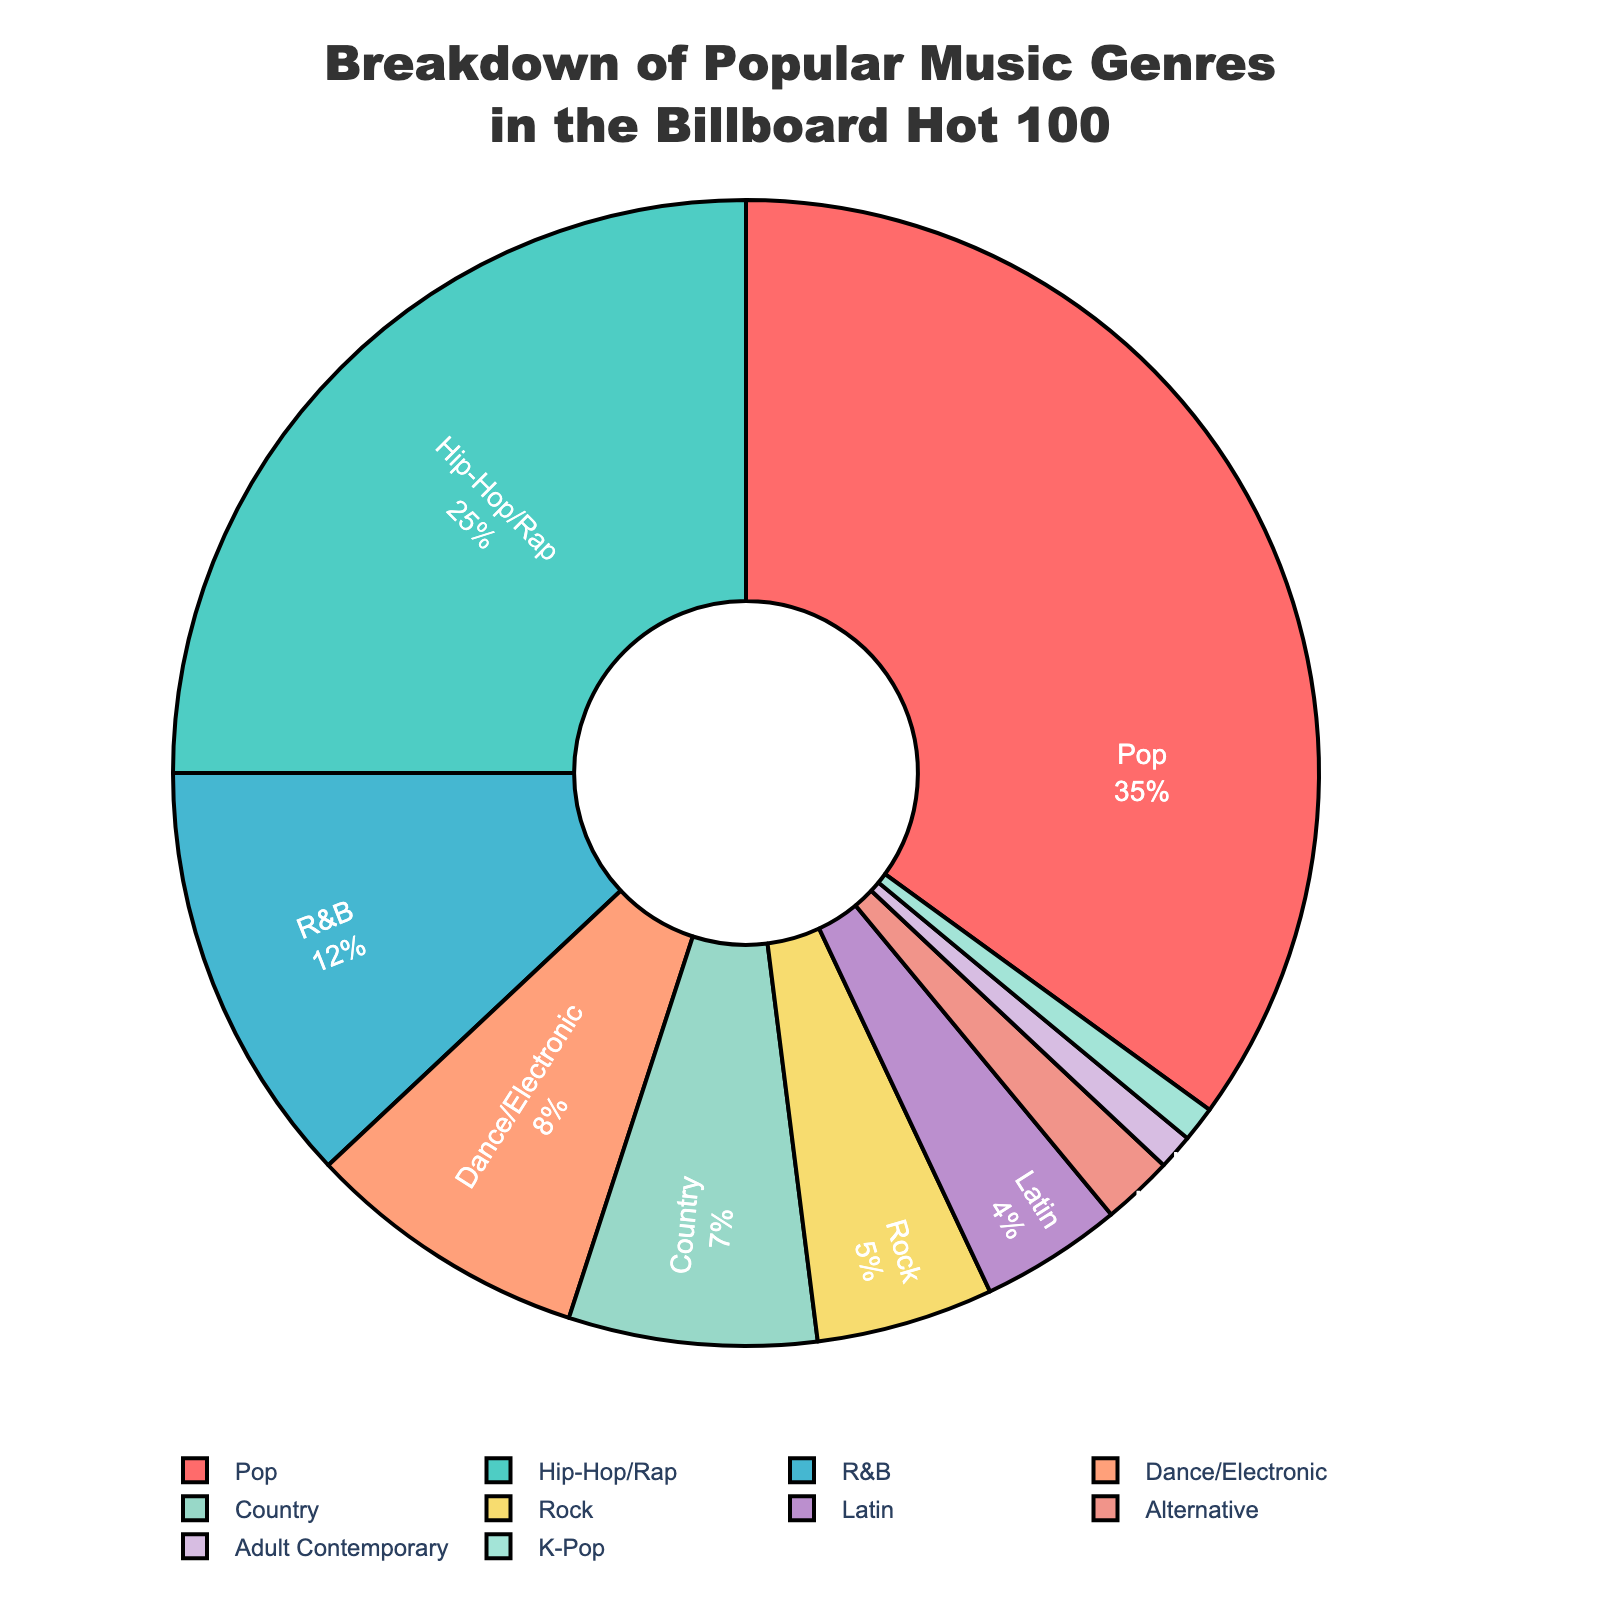What's the most popular music genre in the Billboard Hot 100? The pie chart shows the percentage breakdown of popular music genres, and the genre with the largest percentage is Pop at 35%.
Answer: Pop What's the combined percentage of Hip-Hop/Rap, R&B, and Dance/Electronic genres? To find the combined percentage, add the percentages of Hip-Hop/Rap (25%), R&B (12%), and Dance/Electronic (8%): 25 + 12 + 8 = 45.
Answer: 45 How much more popular is Pop compared to Country in this chart? The percentage for Pop is 35% and for Country is 7%. To find the difference, subtract the percentage of Country from Pop: 35 - 7 = 28.
Answer: 28 Which genre accounts for the smallest percentage of the Billboard Hot 100? The pie chart shows that both Adult Contemporary and K-Pop have the smallest percentages, each at 1%.
Answer: Adult Contemporary and K-Pop If Adult Contemporary and K-Pop were combined into one category, what would be their total percentage? Both Adult Contemporary and K-Pop individually account for 1%, so combined they would account for: 1 + 1 = 2.
Answer: 2 Is the percentage of Pop music more than double that of Hip-Hop/Rap? The percentage of Pop music is 35%, and that of Hip-Hop/Rap is 25%. Double of Hip-Hop/Rap would be 25 × 2 = 50. Since 35% is less than 50%, Pop is not more than double.
Answer: No Which genre has a higher percentage, Rock or Latin? The pie chart shows that Rock accounts for 5% while Latin accounts for 4%. Therefore, Rock has a higher percentage.
Answer: Rock What's the total percentage of genres accounting for less than 10% each? To find the total, add the percentages of R&B (12%), Dance/Electronic (8%), Country (7%), Rock (5%), Latin (4%), Alternative (2%), Adult Contemporary (1%), and K-Pop (1%): 12 + 8 + 7 + 5 + 4 + 2 + 1 + 1 = 40.
Answer: 40 How much more popular is Hip-Hop/Rap compared to Dance/Electronic? The percentage for Hip-Hop/Rap is 25% and for Dance/Electronic is 8%. To find the difference, subtract the percentage of Dance/Electronic from Hip-Hop/Rap: 25 - 8 = 17.
Answer: 17 Which genre is represented by the blue section of the pie chart? The pie chart color code shows that Hip-Hop/Rap is represented by the blue section.
Answer: Hip-Hop/Rap 